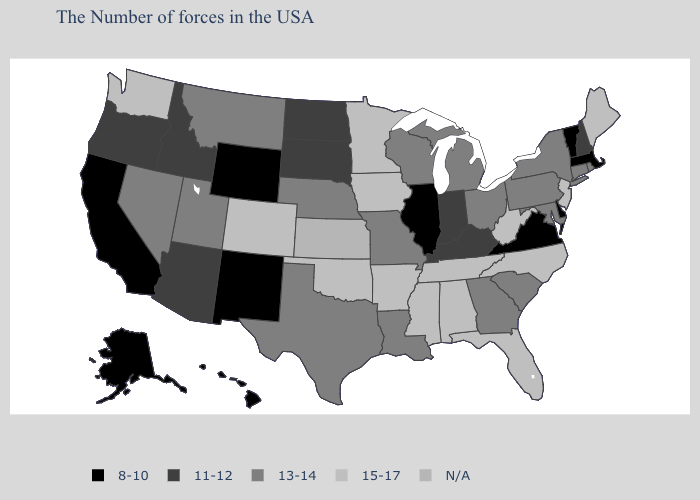What is the value of Connecticut?
Short answer required. 13-14. What is the lowest value in the Northeast?
Short answer required. 8-10. What is the value of Hawaii?
Answer briefly. 8-10. Does the map have missing data?
Give a very brief answer. Yes. Among the states that border New Mexico , which have the highest value?
Write a very short answer. Oklahoma, Colorado. What is the value of South Carolina?
Answer briefly. 13-14. Which states have the lowest value in the MidWest?
Quick response, please. Illinois. Among the states that border Pennsylvania , which have the highest value?
Concise answer only. New Jersey, West Virginia. Does Texas have the lowest value in the USA?
Short answer required. No. What is the value of Wyoming?
Write a very short answer. 8-10. Name the states that have a value in the range 8-10?
Write a very short answer. Massachusetts, Vermont, Delaware, Virginia, Illinois, Wyoming, New Mexico, California, Alaska, Hawaii. Name the states that have a value in the range 15-17?
Be succinct. Maine, New Jersey, North Carolina, West Virginia, Florida, Alabama, Tennessee, Mississippi, Arkansas, Minnesota, Iowa, Oklahoma, Colorado, Washington. Does the first symbol in the legend represent the smallest category?
Write a very short answer. Yes. Name the states that have a value in the range 13-14?
Give a very brief answer. Rhode Island, Connecticut, New York, Maryland, Pennsylvania, South Carolina, Ohio, Georgia, Michigan, Wisconsin, Louisiana, Missouri, Nebraska, Texas, Utah, Montana, Nevada. What is the highest value in the USA?
Quick response, please. 15-17. 